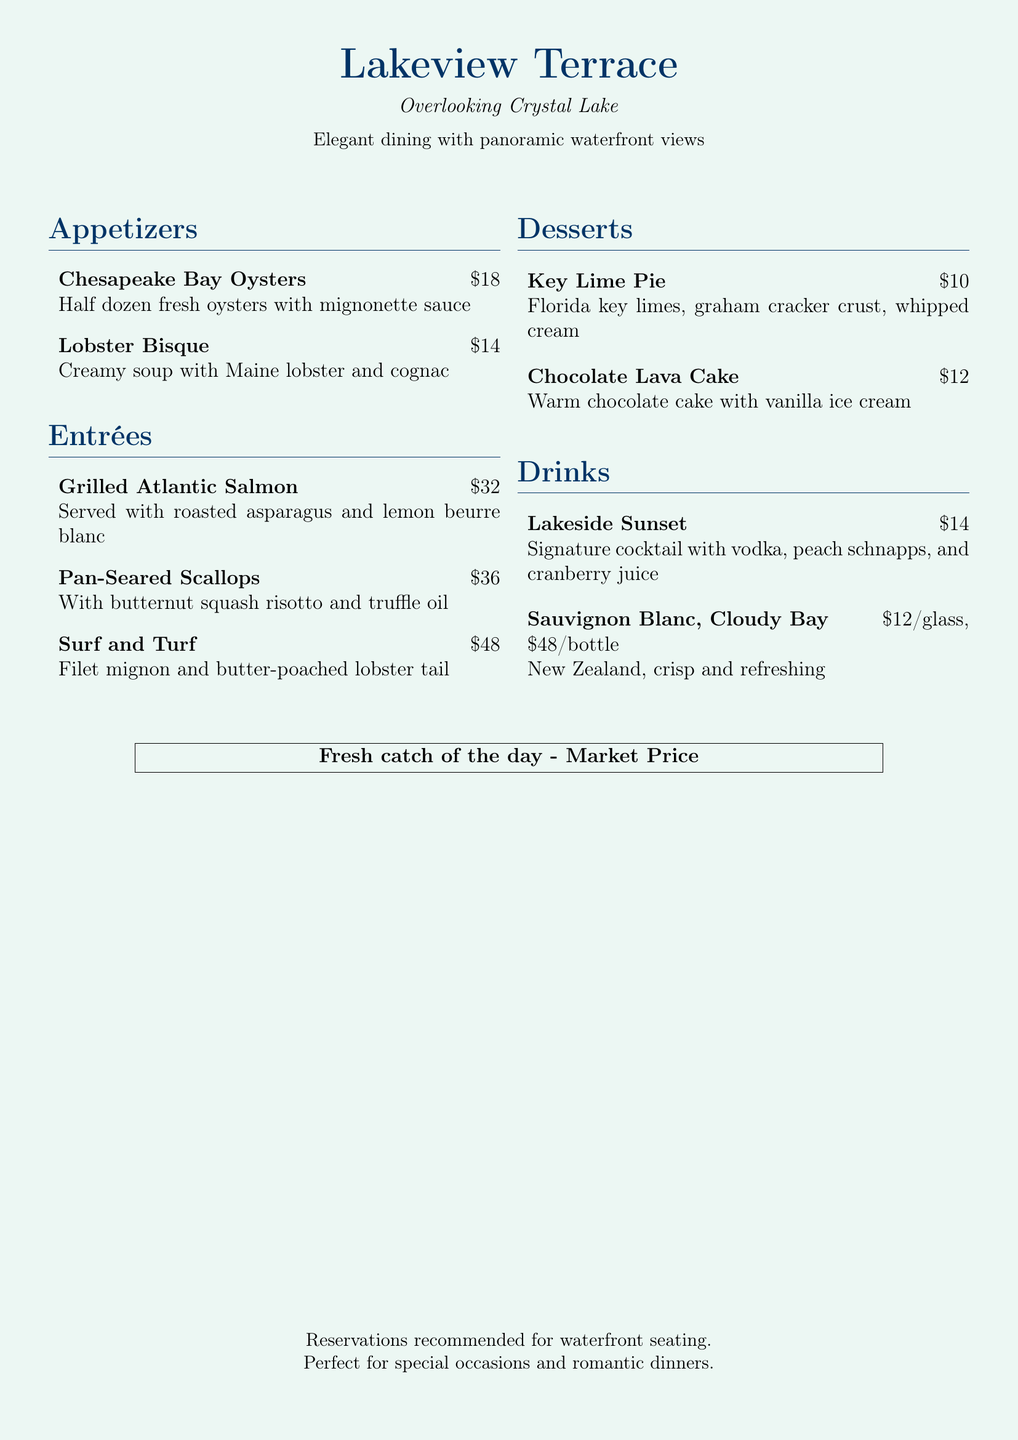What are the fresh oysters served with? The Chesapeake Bay Oysters are served with mignonette sauce.
Answer: mignonette sauce What is the price of the Surf and Turf? The price of the Surf and Turf is listed on the menu.
Answer: $48 How many ounces of the Sauvignon Blanc are offered by the glass? The Sauvignon Blanc is offered at a price per glass and bottle, the glass portion is mentioned.
Answer: 12 What is the dessert that features chocolate? The menu lists a specific dessert that is warm and contains chocolate.
Answer: Chocolate Lava Cake What seafood item is mentioned as the fresh catch of the day? The document specifies that there is a fresh fish option available but does not list a specific name.
Answer: Market Price Which drink is a signature cocktail? The menu explicitly names one cocktail as their signature drink.
Answer: Lakeside Sunset What is served with the Pan-Seared Scallops? The side dish accompanying the Pan-Seared Scallops is written on the menu.
Answer: butternut squash risotto How many appetizers are listed on the menu? The menu contains a specific number of appetizers under the appetizers section.
Answer: 2 What is recommended for special occasions? The document concludes with a recommendation about the setting of the restaurant.
Answer: waterfront seating 